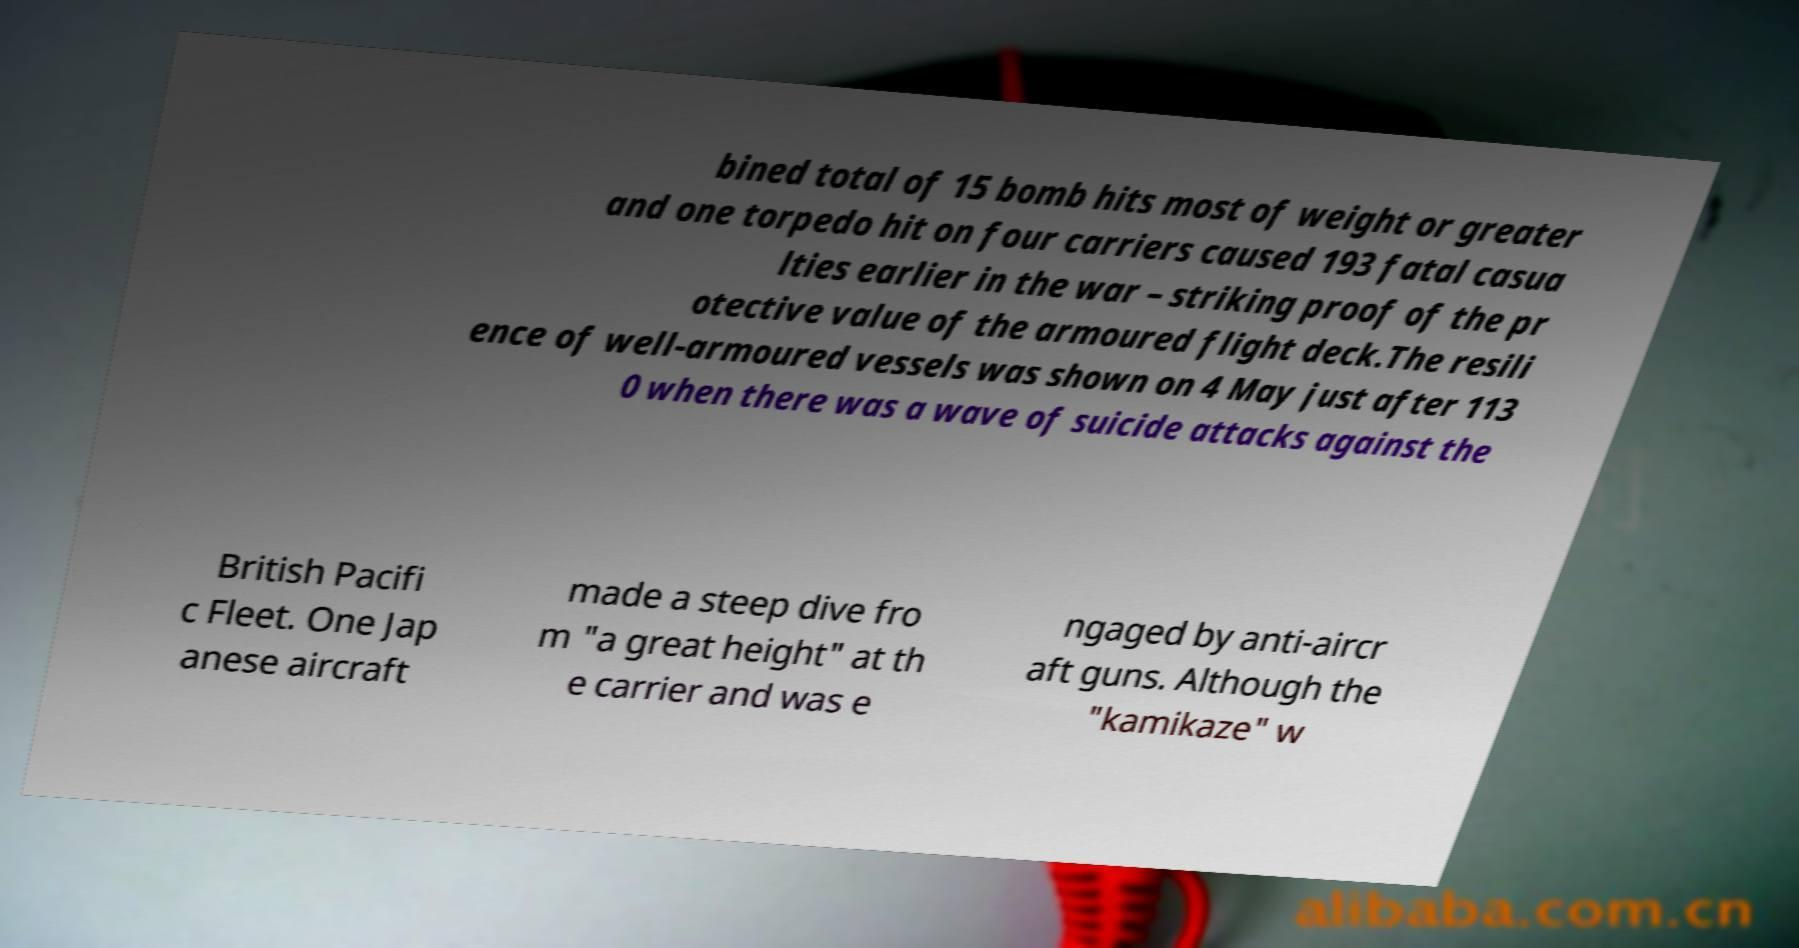Can you accurately transcribe the text from the provided image for me? bined total of 15 bomb hits most of weight or greater and one torpedo hit on four carriers caused 193 fatal casua lties earlier in the war – striking proof of the pr otective value of the armoured flight deck.The resili ence of well-armoured vessels was shown on 4 May just after 113 0 when there was a wave of suicide attacks against the British Pacifi c Fleet. One Jap anese aircraft made a steep dive fro m "a great height" at th e carrier and was e ngaged by anti-aircr aft guns. Although the "kamikaze" w 